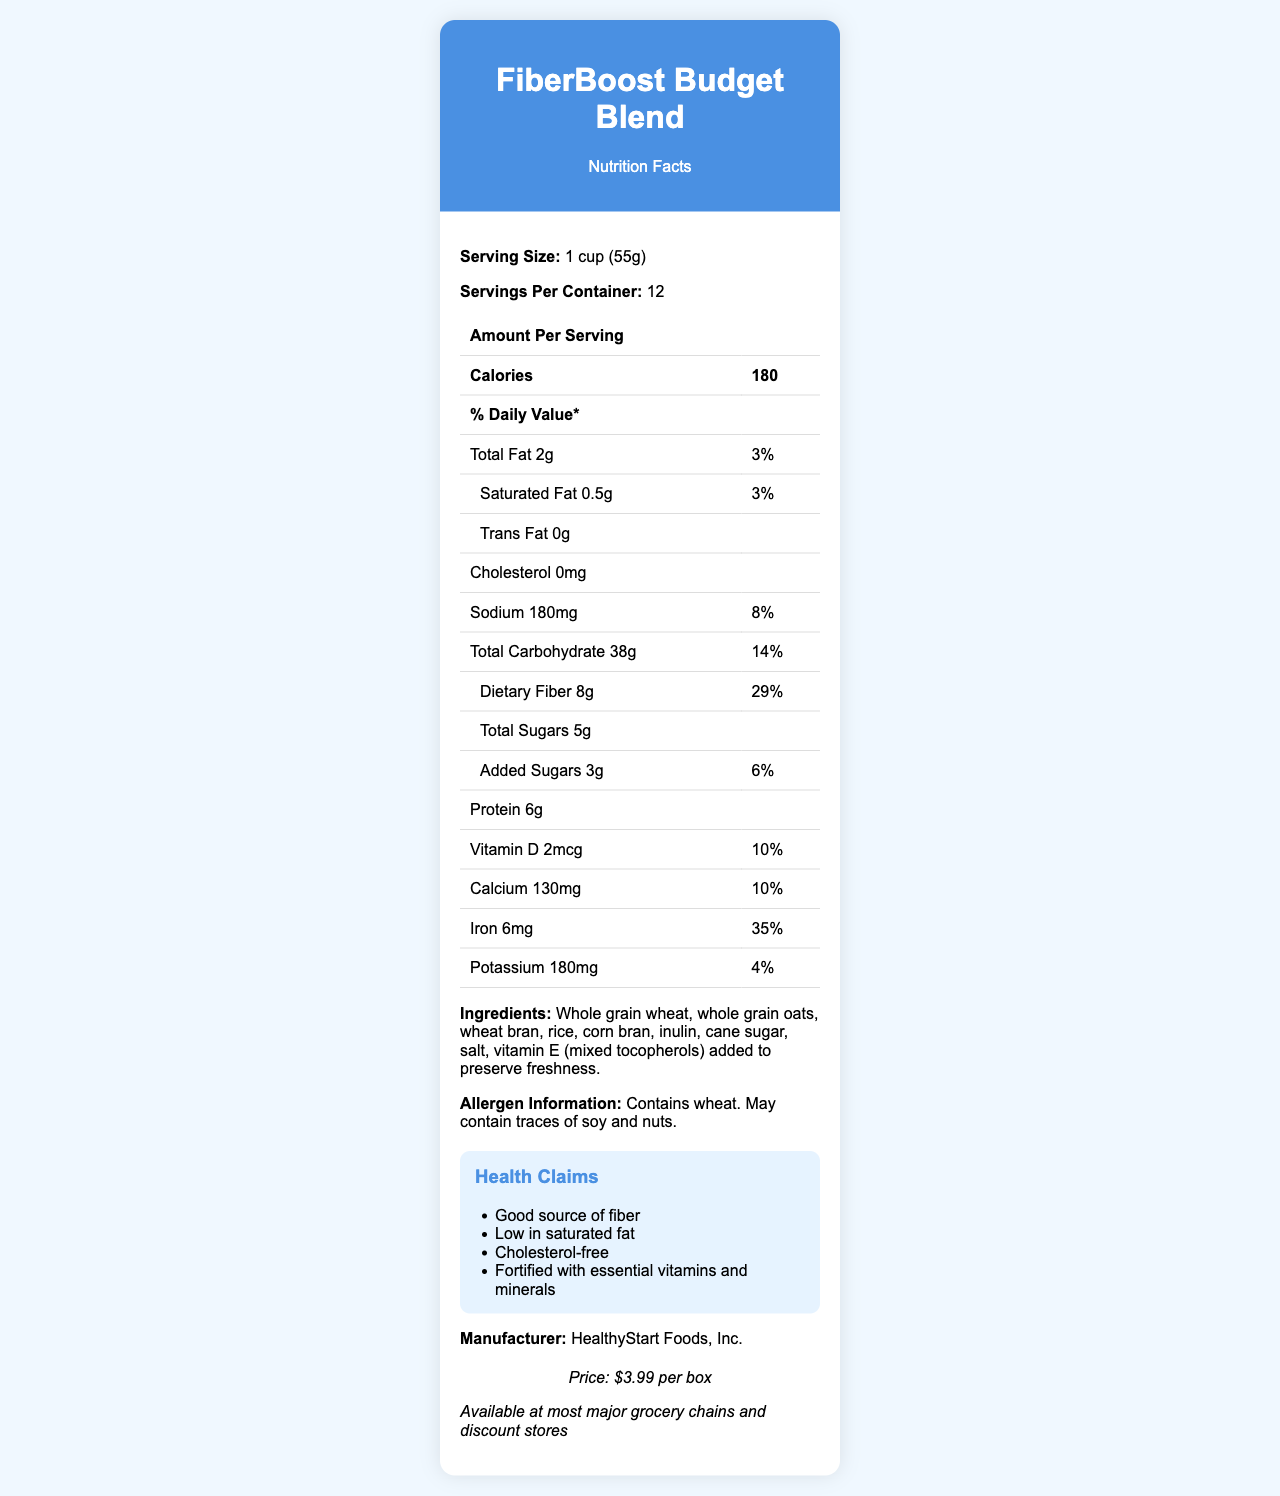What is the serving size of FiberBoost Budget Blend? The serving size is explicitly mentioned as 1 cup (55g) in the Nutrition Facts section of the document.
Answer: 1 cup (55g) How many servings per container are there? The document states there are 12 servings per container.
Answer: 12 How many grams of dietary fiber are there per serving? The document lists 8g of dietary fiber under the Total Carbohydrate section.
Answer: 8g What is the total amount of sugars per serving? According to the Nutrition Facts, the total sugars per serving is 5g.
Answer: 5g How much protein is there per serving? The amount of protein per serving is clearly mentioned as 6g in the Nutrition Facts.
Answer: 6g What is the price of one box of FiberBoost Budget Blend? A. $2.99 B. $3.99 C. $4.99 D. $5.99 The document states that the price per box is $3.99.
Answer: B Which of the following ingredients is NOT listed in the cereal? A. Whole grain wheat B. Rice C. Corn bran D. Soy The ingredients list includes whole grain wheat, rice, and corn bran but does not mention soy.
Answer: D Is this product low in saturated fat? The product's health claims section states that it is "Low in saturated fat," which is confirmed by the 3% daily value for saturated fat in the Nutrition Facts.
Answer: Yes Summarize the key highlights of the nutrition facts document for FiberBoost Budget Blend. The document provides detailed nutrition facts, including caloric content, macronutrients, and vitamins and minerals. Additionally, it mentions health claims, allergen information, price, and availability.
Answer: FiberBoost Budget Blend is a high-fiber, low-sugar breakfast cereal with 8g of dietary fiber and 5g of total sugars per serving. Each serving contains 180 calories, 2g total fat, and 6g of protein. The product is low in saturated fat, cholesterol-free, and fortified with essential vitamins and minerals, including iron and vitamin D. The cereal is priced at $3.99 per box and is available at major grocery chains and discount stores. What are the health claims made for this cereal? The health claims are listed in a separate section and include being a good source of fiber, low in saturated fat, cholesterol-free, and fortified with essential vitamins and minerals.
Answer: Good source of fiber, Low in saturated fat, Cholesterol-free, Fortified with essential vitamins and minerals What percentage of the daily value for iron does one serving provide? The document states that one serving provides 35% of the daily value for iron.
Answer: 35% What is the total fat content per serving? A. 1g B. 2g C. 3g D. 0.5g The document lists the total fat content as 2g per serving.
Answer: B Is there any cholesterol in this cereal? The nutrition facts explicitly state that the cholesterol content is 0mg.
Answer: No What is the exact amount of vitamin D per serving? The document states that there are 2mcg of vitamin D per serving.
Answer: 2mcg How many calories are in one serving of FiberBoost Budget Blend? The document states that one serving contains 180 calories.
Answer: 180 Does the ingredient list include any artificial colors or preservatives? The ingredient list includes natural ingredients like whole grains and does not mention any artificial colors or preservatives.
Answer: No Does the cereal contain any traces of nuts? The allergen information section says that the product may contain traces of soy and nuts.
Answer: May contain traces of soy and nuts Can you list all the minerals included in the nutrition facts? The document lists calcium (130mg), iron (6mg), and potassium (180mg) in the nutrition facts.
Answer: Calcium, Iron, Potassium What are the trace potential allergens in this product? The allergen information indicates that the product may contain traces of soy and nuts.
Answer: Soy and nuts Is the product available online? The document only mentions that the product is available at major grocery chains and discount stores but does not specify online availability.
Answer: Not enough information 